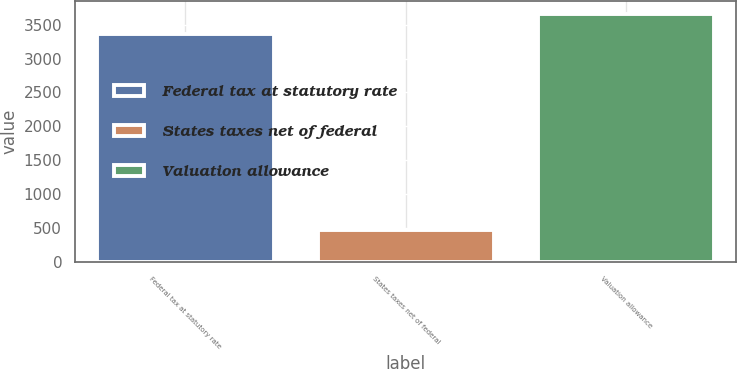Convert chart to OTSL. <chart><loc_0><loc_0><loc_500><loc_500><bar_chart><fcel>Federal tax at statutory rate<fcel>States taxes net of federal<fcel>Valuation allowance<nl><fcel>3368<fcel>481<fcel>3659.8<nl></chart> 